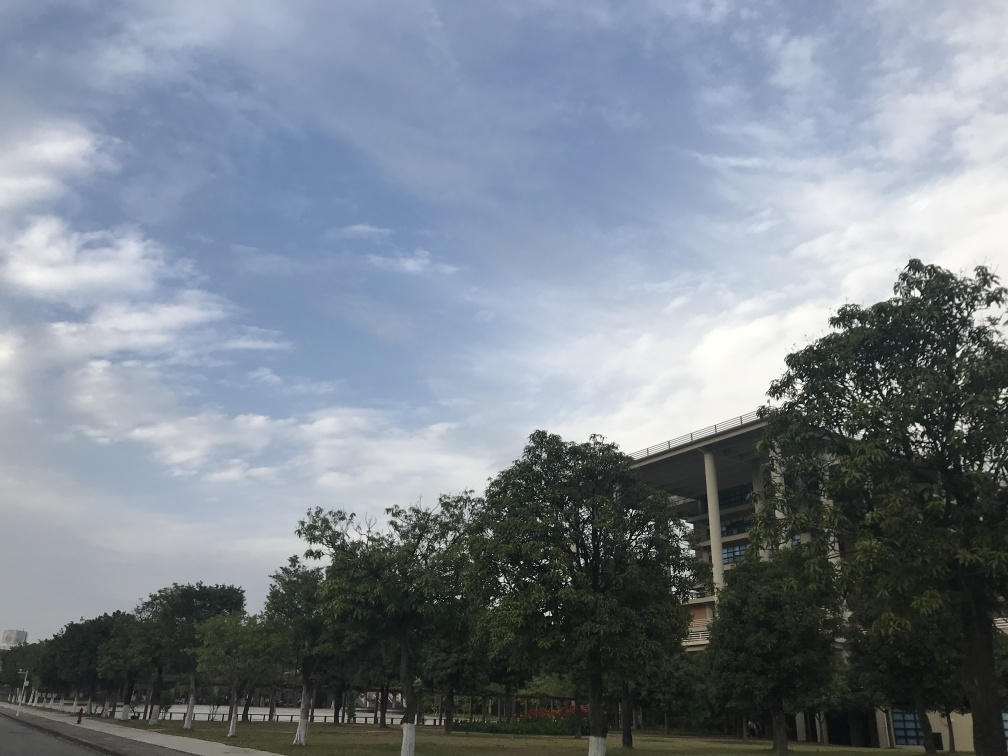Are there any signs of human activity in the image? There are no visible human figures or vehicles in the picture, which gives the scene a deserted look. However, the structured landscaping and maintained appearance of the trees and grassy areas indicate that the area is likely frequented by people, even though none are captured in this moment. 